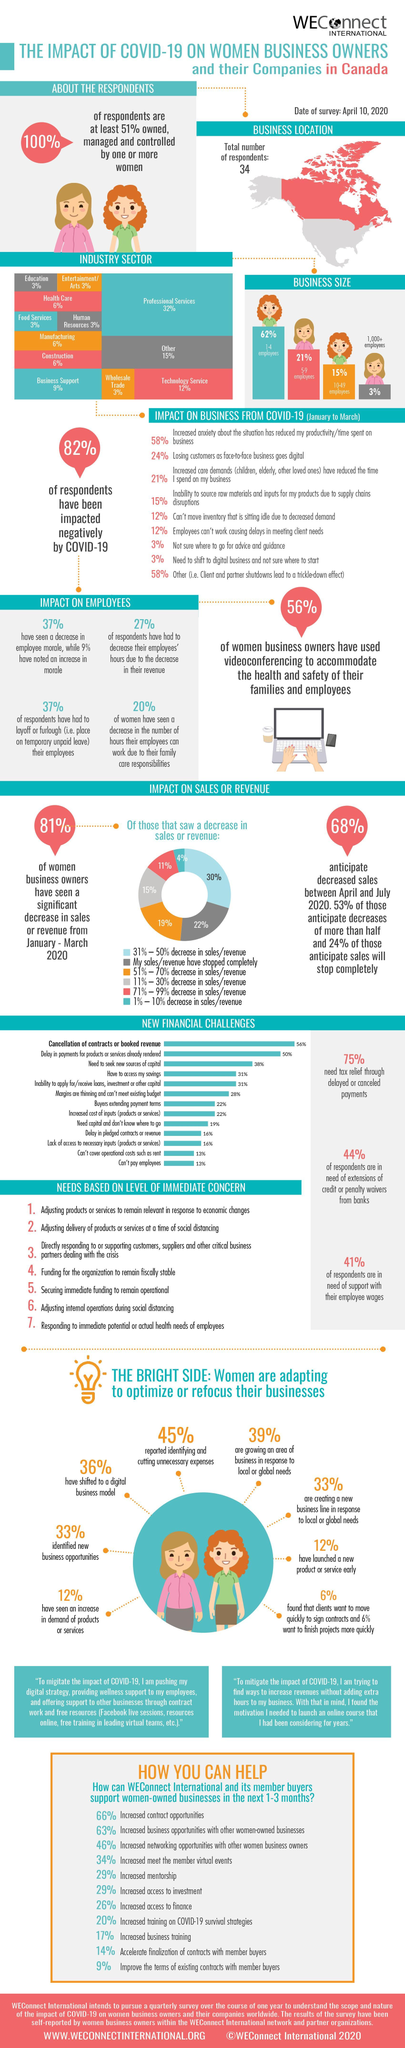What percent of respondents see a 51-70% decrease in sales/revenue?
Answer the question with a short phrase. 19% How many women are shown n the infographic? 8 What percent of respondents have not been negatively impacted by COVID-19? 18% What percent of women have shifted to a digital business model as well as identified new business opportunities? 69% What is the biggest financial challenge? Cancellation of contracts or booked revenue What do 11% of respondents anticipate about decrease in sales/revenue according to pie chart? 71% - 99% decrease in sales/revenue What percent of businesses have 1-9 employees? 83% 